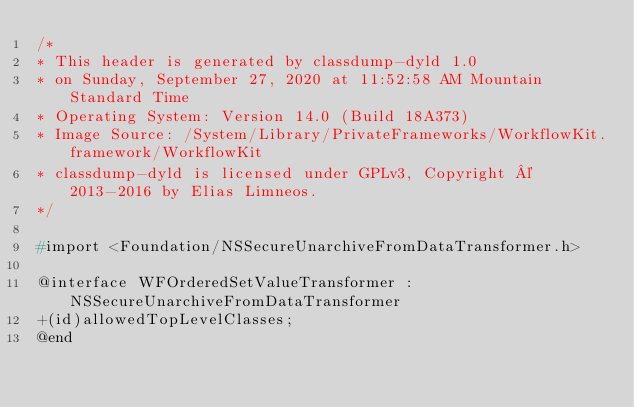Convert code to text. <code><loc_0><loc_0><loc_500><loc_500><_C_>/*
* This header is generated by classdump-dyld 1.0
* on Sunday, September 27, 2020 at 11:52:58 AM Mountain Standard Time
* Operating System: Version 14.0 (Build 18A373)
* Image Source: /System/Library/PrivateFrameworks/WorkflowKit.framework/WorkflowKit
* classdump-dyld is licensed under GPLv3, Copyright © 2013-2016 by Elias Limneos.
*/

#import <Foundation/NSSecureUnarchiveFromDataTransformer.h>

@interface WFOrderedSetValueTransformer : NSSecureUnarchiveFromDataTransformer
+(id)allowedTopLevelClasses;
@end

</code> 